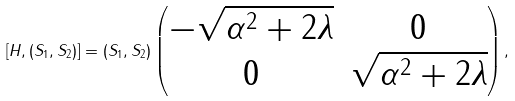Convert formula to latex. <formula><loc_0><loc_0><loc_500><loc_500>[ H , ( S _ { 1 } , S _ { 2 } ) ] = ( S _ { 1 } , S _ { 2 } ) \left ( \begin{matrix} - \sqrt { \alpha ^ { 2 } + 2 \lambda } & 0 \\ 0 & \sqrt { \alpha ^ { 2 } + 2 \lambda } \end{matrix} \right ) ,</formula> 